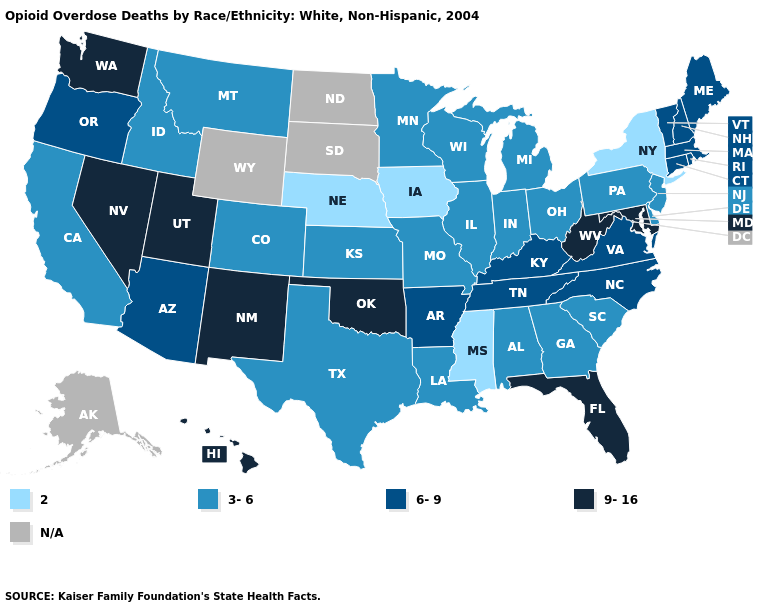Among the states that border Idaho , which have the highest value?
Give a very brief answer. Nevada, Utah, Washington. What is the lowest value in the USA?
Quick response, please. 2. Does the map have missing data?
Write a very short answer. Yes. Among the states that border New Mexico , does Oklahoma have the highest value?
Write a very short answer. Yes. Does Kentucky have the lowest value in the USA?
Answer briefly. No. Name the states that have a value in the range 6-9?
Keep it brief. Arizona, Arkansas, Connecticut, Kentucky, Maine, Massachusetts, New Hampshire, North Carolina, Oregon, Rhode Island, Tennessee, Vermont, Virginia. What is the value of Hawaii?
Give a very brief answer. 9-16. Name the states that have a value in the range 6-9?
Write a very short answer. Arizona, Arkansas, Connecticut, Kentucky, Maine, Massachusetts, New Hampshire, North Carolina, Oregon, Rhode Island, Tennessee, Vermont, Virginia. Among the states that border New York , which have the highest value?
Answer briefly. Connecticut, Massachusetts, Vermont. Which states have the highest value in the USA?
Be succinct. Florida, Hawaii, Maryland, Nevada, New Mexico, Oklahoma, Utah, Washington, West Virginia. Does Wisconsin have the lowest value in the USA?
Keep it brief. No. Name the states that have a value in the range 9-16?
Give a very brief answer. Florida, Hawaii, Maryland, Nevada, New Mexico, Oklahoma, Utah, Washington, West Virginia. Does Oklahoma have the highest value in the USA?
Give a very brief answer. Yes. 